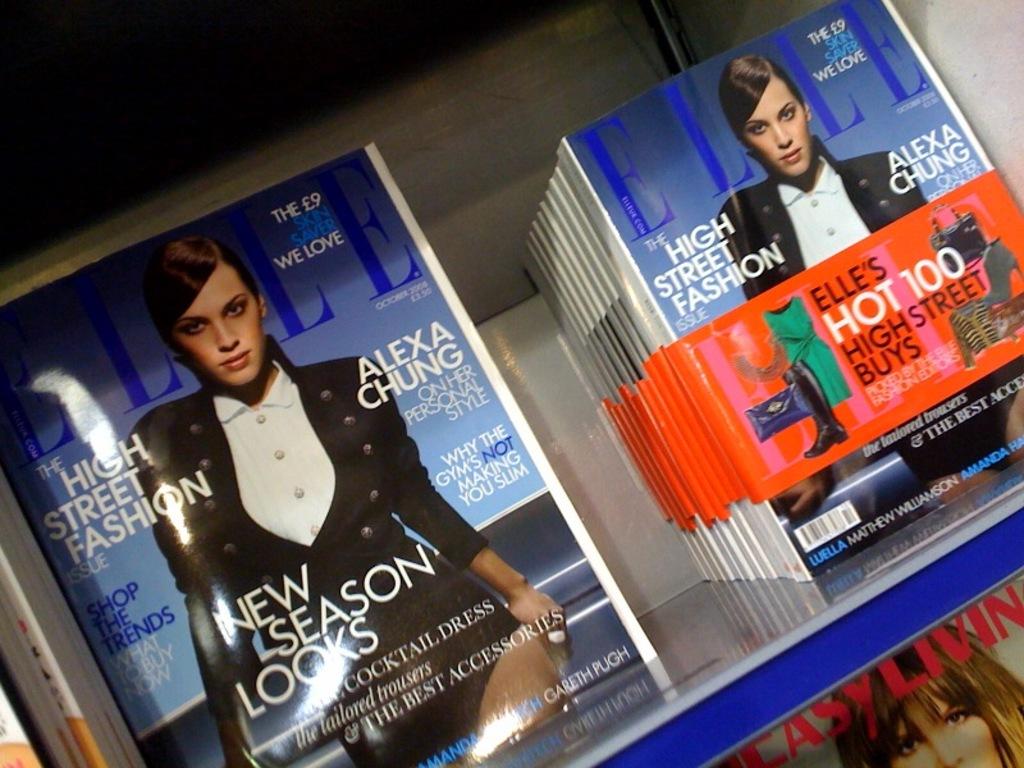What is the right magazine title?
Keep it short and to the point. Elle. 